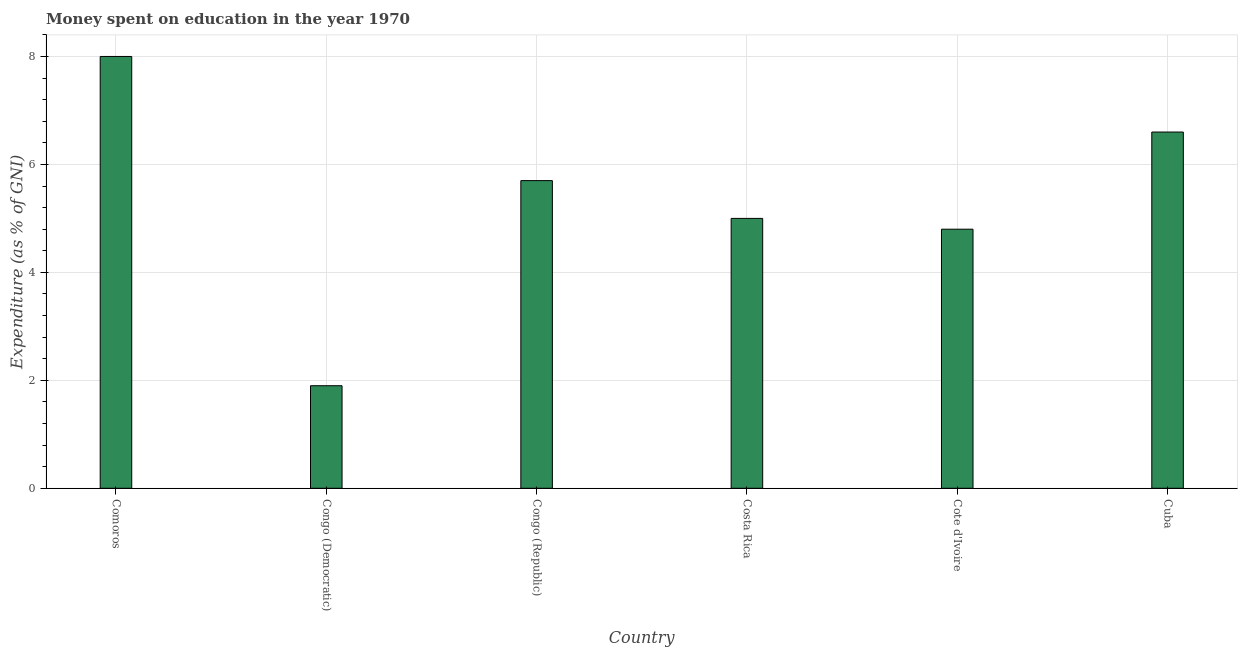Does the graph contain any zero values?
Your answer should be compact. No. What is the title of the graph?
Make the answer very short. Money spent on education in the year 1970. What is the label or title of the Y-axis?
Make the answer very short. Expenditure (as % of GNI). What is the expenditure on education in Cuba?
Keep it short and to the point. 6.6. Across all countries, what is the minimum expenditure on education?
Provide a short and direct response. 1.9. In which country was the expenditure on education maximum?
Offer a terse response. Comoros. In which country was the expenditure on education minimum?
Provide a short and direct response. Congo (Democratic). What is the average expenditure on education per country?
Make the answer very short. 5.33. What is the median expenditure on education?
Keep it short and to the point. 5.35. What is the ratio of the expenditure on education in Congo (Republic) to that in Cote d'Ivoire?
Ensure brevity in your answer.  1.19. Is the difference between the expenditure on education in Congo (Republic) and Cuba greater than the difference between any two countries?
Keep it short and to the point. No. What is the difference between the highest and the second highest expenditure on education?
Your response must be concise. 1.4. What is the difference between the highest and the lowest expenditure on education?
Provide a short and direct response. 6.1. How many bars are there?
Offer a terse response. 6. Are all the bars in the graph horizontal?
Your response must be concise. No. How many countries are there in the graph?
Provide a short and direct response. 6. What is the Expenditure (as % of GNI) of Congo (Democratic)?
Offer a terse response. 1.9. What is the Expenditure (as % of GNI) in Cote d'Ivoire?
Keep it short and to the point. 4.8. What is the difference between the Expenditure (as % of GNI) in Comoros and Congo (Democratic)?
Offer a terse response. 6.1. What is the difference between the Expenditure (as % of GNI) in Comoros and Costa Rica?
Offer a terse response. 3. What is the difference between the Expenditure (as % of GNI) in Comoros and Cote d'Ivoire?
Offer a very short reply. 3.2. What is the difference between the Expenditure (as % of GNI) in Comoros and Cuba?
Offer a very short reply. 1.4. What is the difference between the Expenditure (as % of GNI) in Congo (Democratic) and Cote d'Ivoire?
Make the answer very short. -2.9. What is the difference between the Expenditure (as % of GNI) in Congo (Democratic) and Cuba?
Provide a succinct answer. -4.7. What is the difference between the Expenditure (as % of GNI) in Congo (Republic) and Cote d'Ivoire?
Provide a short and direct response. 0.9. What is the difference between the Expenditure (as % of GNI) in Congo (Republic) and Cuba?
Make the answer very short. -0.9. What is the difference between the Expenditure (as % of GNI) in Costa Rica and Cote d'Ivoire?
Your answer should be compact. 0.2. What is the difference between the Expenditure (as % of GNI) in Costa Rica and Cuba?
Your answer should be very brief. -1.6. What is the ratio of the Expenditure (as % of GNI) in Comoros to that in Congo (Democratic)?
Give a very brief answer. 4.21. What is the ratio of the Expenditure (as % of GNI) in Comoros to that in Congo (Republic)?
Give a very brief answer. 1.4. What is the ratio of the Expenditure (as % of GNI) in Comoros to that in Costa Rica?
Give a very brief answer. 1.6. What is the ratio of the Expenditure (as % of GNI) in Comoros to that in Cote d'Ivoire?
Ensure brevity in your answer.  1.67. What is the ratio of the Expenditure (as % of GNI) in Comoros to that in Cuba?
Keep it short and to the point. 1.21. What is the ratio of the Expenditure (as % of GNI) in Congo (Democratic) to that in Congo (Republic)?
Offer a terse response. 0.33. What is the ratio of the Expenditure (as % of GNI) in Congo (Democratic) to that in Costa Rica?
Give a very brief answer. 0.38. What is the ratio of the Expenditure (as % of GNI) in Congo (Democratic) to that in Cote d'Ivoire?
Your answer should be very brief. 0.4. What is the ratio of the Expenditure (as % of GNI) in Congo (Democratic) to that in Cuba?
Provide a succinct answer. 0.29. What is the ratio of the Expenditure (as % of GNI) in Congo (Republic) to that in Costa Rica?
Make the answer very short. 1.14. What is the ratio of the Expenditure (as % of GNI) in Congo (Republic) to that in Cote d'Ivoire?
Give a very brief answer. 1.19. What is the ratio of the Expenditure (as % of GNI) in Congo (Republic) to that in Cuba?
Your answer should be very brief. 0.86. What is the ratio of the Expenditure (as % of GNI) in Costa Rica to that in Cote d'Ivoire?
Offer a terse response. 1.04. What is the ratio of the Expenditure (as % of GNI) in Costa Rica to that in Cuba?
Give a very brief answer. 0.76. What is the ratio of the Expenditure (as % of GNI) in Cote d'Ivoire to that in Cuba?
Provide a short and direct response. 0.73. 